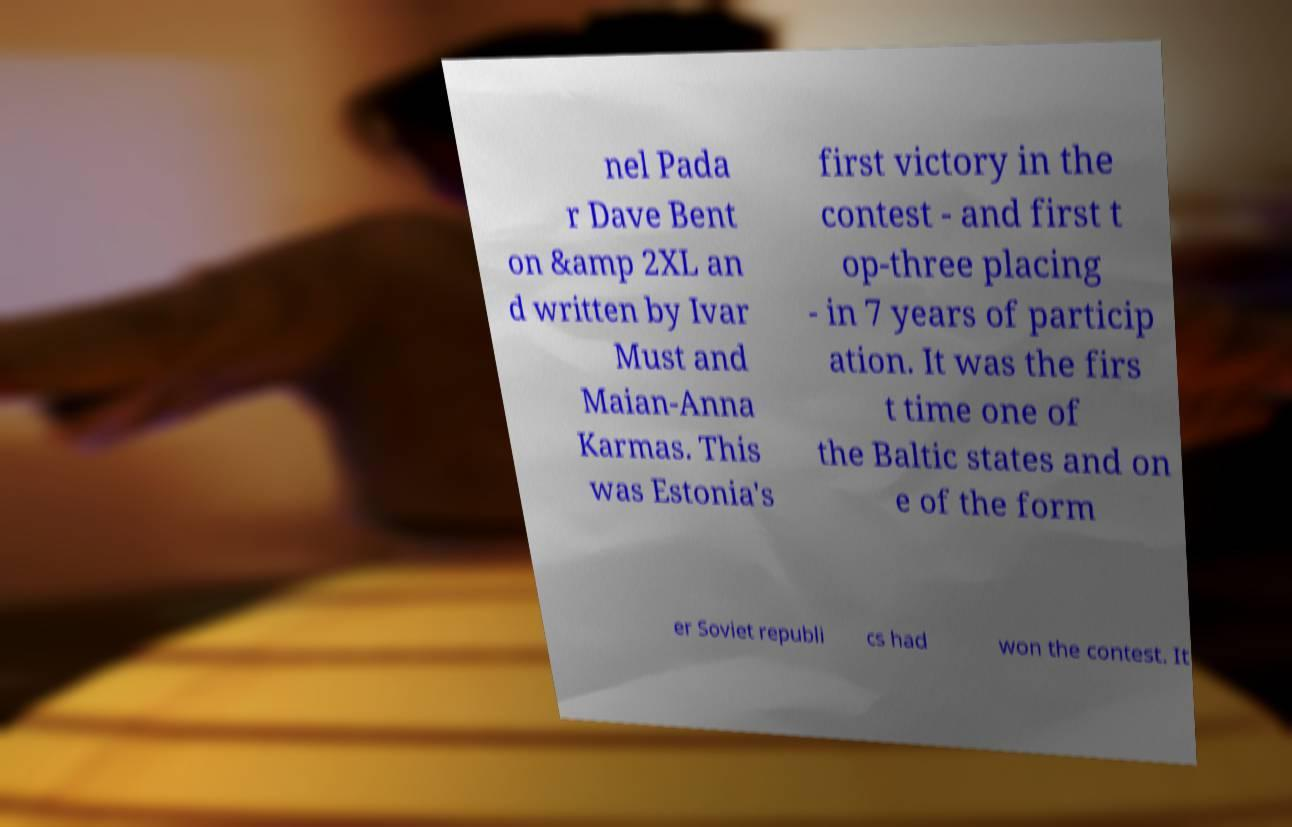Could you extract and type out the text from this image? nel Pada r Dave Bent on &amp 2XL an d written by Ivar Must and Maian-Anna Karmas. This was Estonia's first victory in the contest - and first t op-three placing - in 7 years of particip ation. It was the firs t time one of the Baltic states and on e of the form er Soviet republi cs had won the contest. It 